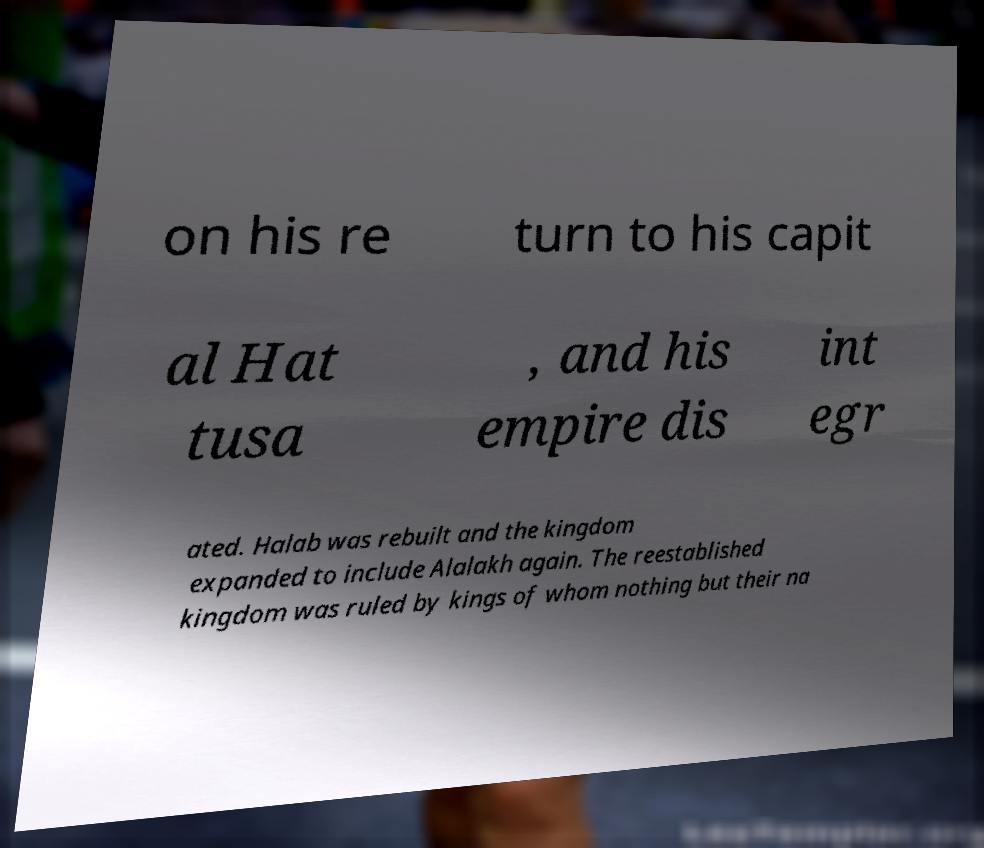Could you assist in decoding the text presented in this image and type it out clearly? on his re turn to his capit al Hat tusa , and his empire dis int egr ated. Halab was rebuilt and the kingdom expanded to include Alalakh again. The reestablished kingdom was ruled by kings of whom nothing but their na 